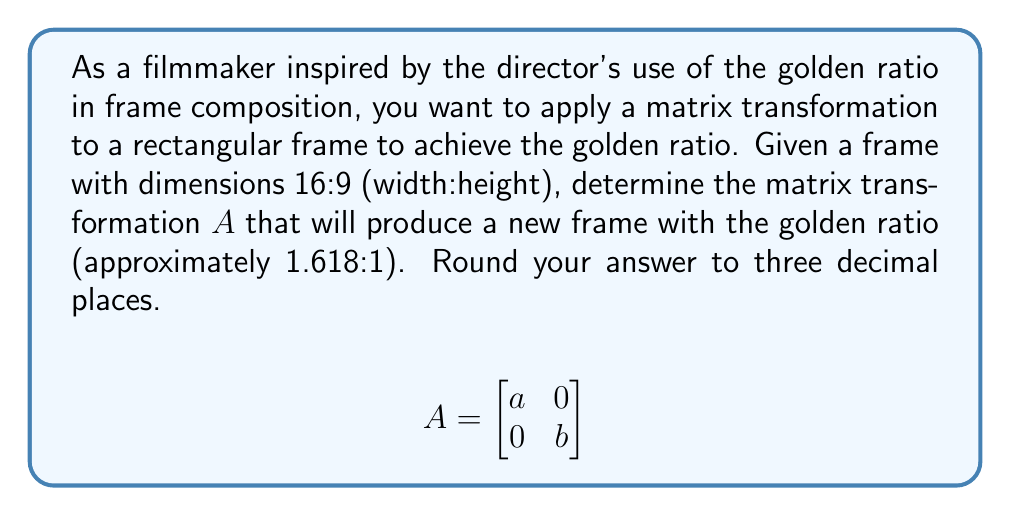Can you solve this math problem? To solve this problem, we'll follow these steps:

1) The golden ratio is approximately 1.618:1. Let's call this value $\phi$.

2) The current frame ratio is 16:9. We need to transform this to $\phi$:1.

3) We can represent this transformation as:

   $$\frac{16a}{9b} = \phi$$

4) We want to minimize the change to the frame, so let's keep the height constant. This means $b = 1$.

5) Substituting $b = 1$ and $\phi \approx 1.618$ into our equation:

   $$\frac{16a}{9} = 1.618$$

6) Solving for $a$:

   $$16a = 1.618 * 9$$
   $$16a = 14.562$$
   $$a = \frac{14.562}{16} = 0.910125$$

7) Rounding to three decimal places:

   $$a = 0.910$$

Therefore, the transformation matrix $A$ is:

$$A = \begin{bmatrix} 0.910 & 0 \\ 0 & 1 \end{bmatrix}$$

This matrix will slightly compress the width of the frame while keeping the height constant, resulting in a new frame with the golden ratio.
Answer: $$A = \begin{bmatrix} 0.910 & 0 \\ 0 & 1 \end{bmatrix}$$ 